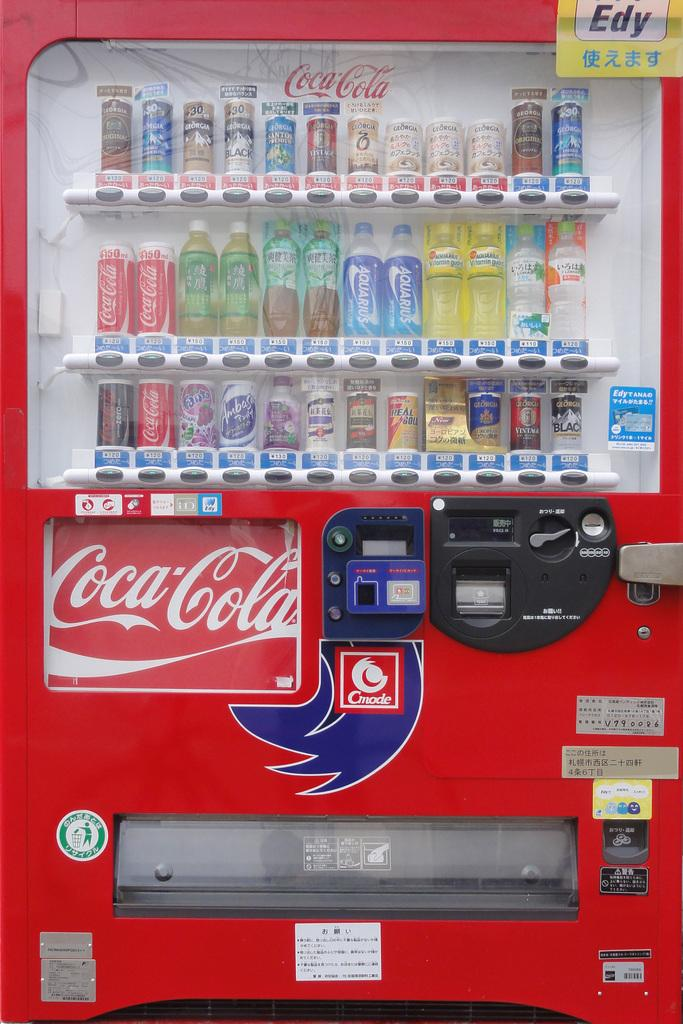<image>
Provide a brief description of the given image. An unusual Coca Cola vending machine.with water also. 